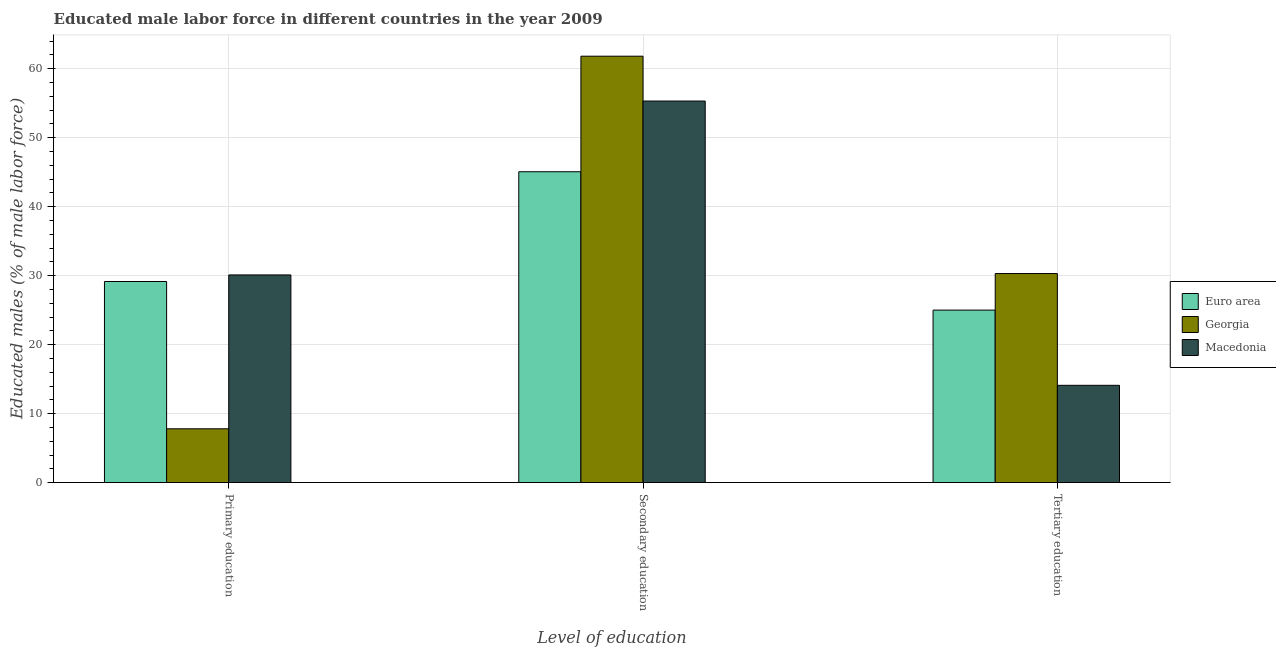Are the number of bars on each tick of the X-axis equal?
Your answer should be very brief. Yes. What is the label of the 2nd group of bars from the left?
Your answer should be very brief. Secondary education. What is the percentage of male labor force who received secondary education in Euro area?
Provide a succinct answer. 45.05. Across all countries, what is the maximum percentage of male labor force who received tertiary education?
Ensure brevity in your answer.  30.3. Across all countries, what is the minimum percentage of male labor force who received primary education?
Ensure brevity in your answer.  7.8. In which country was the percentage of male labor force who received primary education maximum?
Provide a short and direct response. Macedonia. In which country was the percentage of male labor force who received secondary education minimum?
Provide a succinct answer. Euro area. What is the total percentage of male labor force who received tertiary education in the graph?
Provide a succinct answer. 69.4. What is the difference between the percentage of male labor force who received primary education in Euro area and that in Macedonia?
Give a very brief answer. -0.95. What is the difference between the percentage of male labor force who received tertiary education in Macedonia and the percentage of male labor force who received secondary education in Euro area?
Your answer should be very brief. -30.95. What is the average percentage of male labor force who received secondary education per country?
Keep it short and to the point. 54.05. What is the difference between the percentage of male labor force who received tertiary education and percentage of male labor force who received secondary education in Georgia?
Your answer should be compact. -31.5. What is the ratio of the percentage of male labor force who received tertiary education in Euro area to that in Georgia?
Ensure brevity in your answer.  0.83. Is the percentage of male labor force who received secondary education in Georgia less than that in Macedonia?
Provide a succinct answer. No. Is the difference between the percentage of male labor force who received tertiary education in Georgia and Macedonia greater than the difference between the percentage of male labor force who received secondary education in Georgia and Macedonia?
Keep it short and to the point. Yes. What is the difference between the highest and the second highest percentage of male labor force who received primary education?
Your answer should be very brief. 0.95. What is the difference between the highest and the lowest percentage of male labor force who received primary education?
Offer a very short reply. 22.3. In how many countries, is the percentage of male labor force who received primary education greater than the average percentage of male labor force who received primary education taken over all countries?
Your response must be concise. 2. Is the sum of the percentage of male labor force who received tertiary education in Macedonia and Euro area greater than the maximum percentage of male labor force who received primary education across all countries?
Offer a very short reply. Yes. What does the 3rd bar from the left in Tertiary education represents?
Offer a very short reply. Macedonia. What does the 3rd bar from the right in Tertiary education represents?
Give a very brief answer. Euro area. Is it the case that in every country, the sum of the percentage of male labor force who received primary education and percentage of male labor force who received secondary education is greater than the percentage of male labor force who received tertiary education?
Provide a succinct answer. Yes. What is the difference between two consecutive major ticks on the Y-axis?
Your answer should be compact. 10. Are the values on the major ticks of Y-axis written in scientific E-notation?
Ensure brevity in your answer.  No. Does the graph contain any zero values?
Your answer should be very brief. No. Where does the legend appear in the graph?
Provide a succinct answer. Center right. How many legend labels are there?
Provide a short and direct response. 3. What is the title of the graph?
Keep it short and to the point. Educated male labor force in different countries in the year 2009. Does "Middle income" appear as one of the legend labels in the graph?
Ensure brevity in your answer.  No. What is the label or title of the X-axis?
Your response must be concise. Level of education. What is the label or title of the Y-axis?
Provide a succinct answer. Educated males (% of male labor force). What is the Educated males (% of male labor force) of Euro area in Primary education?
Your response must be concise. 29.15. What is the Educated males (% of male labor force) in Georgia in Primary education?
Ensure brevity in your answer.  7.8. What is the Educated males (% of male labor force) in Macedonia in Primary education?
Your answer should be very brief. 30.1. What is the Educated males (% of male labor force) of Euro area in Secondary education?
Your response must be concise. 45.05. What is the Educated males (% of male labor force) in Georgia in Secondary education?
Your answer should be compact. 61.8. What is the Educated males (% of male labor force) in Macedonia in Secondary education?
Offer a very short reply. 55.3. What is the Educated males (% of male labor force) of Euro area in Tertiary education?
Your answer should be compact. 25. What is the Educated males (% of male labor force) in Georgia in Tertiary education?
Your answer should be compact. 30.3. What is the Educated males (% of male labor force) of Macedonia in Tertiary education?
Your answer should be compact. 14.1. Across all Level of education, what is the maximum Educated males (% of male labor force) in Euro area?
Provide a succinct answer. 45.05. Across all Level of education, what is the maximum Educated males (% of male labor force) of Georgia?
Ensure brevity in your answer.  61.8. Across all Level of education, what is the maximum Educated males (% of male labor force) in Macedonia?
Your answer should be compact. 55.3. Across all Level of education, what is the minimum Educated males (% of male labor force) of Euro area?
Your response must be concise. 25. Across all Level of education, what is the minimum Educated males (% of male labor force) in Georgia?
Give a very brief answer. 7.8. Across all Level of education, what is the minimum Educated males (% of male labor force) in Macedonia?
Your response must be concise. 14.1. What is the total Educated males (% of male labor force) in Euro area in the graph?
Your answer should be very brief. 99.2. What is the total Educated males (% of male labor force) in Georgia in the graph?
Offer a terse response. 99.9. What is the total Educated males (% of male labor force) in Macedonia in the graph?
Provide a succinct answer. 99.5. What is the difference between the Educated males (% of male labor force) of Euro area in Primary education and that in Secondary education?
Your answer should be very brief. -15.91. What is the difference between the Educated males (% of male labor force) in Georgia in Primary education and that in Secondary education?
Offer a very short reply. -54. What is the difference between the Educated males (% of male labor force) of Macedonia in Primary education and that in Secondary education?
Offer a very short reply. -25.2. What is the difference between the Educated males (% of male labor force) of Euro area in Primary education and that in Tertiary education?
Your response must be concise. 4.15. What is the difference between the Educated males (% of male labor force) in Georgia in Primary education and that in Tertiary education?
Give a very brief answer. -22.5. What is the difference between the Educated males (% of male labor force) of Macedonia in Primary education and that in Tertiary education?
Offer a very short reply. 16. What is the difference between the Educated males (% of male labor force) in Euro area in Secondary education and that in Tertiary education?
Offer a terse response. 20.05. What is the difference between the Educated males (% of male labor force) in Georgia in Secondary education and that in Tertiary education?
Keep it short and to the point. 31.5. What is the difference between the Educated males (% of male labor force) of Macedonia in Secondary education and that in Tertiary education?
Your answer should be very brief. 41.2. What is the difference between the Educated males (% of male labor force) of Euro area in Primary education and the Educated males (% of male labor force) of Georgia in Secondary education?
Ensure brevity in your answer.  -32.65. What is the difference between the Educated males (% of male labor force) in Euro area in Primary education and the Educated males (% of male labor force) in Macedonia in Secondary education?
Make the answer very short. -26.15. What is the difference between the Educated males (% of male labor force) in Georgia in Primary education and the Educated males (% of male labor force) in Macedonia in Secondary education?
Your response must be concise. -47.5. What is the difference between the Educated males (% of male labor force) in Euro area in Primary education and the Educated males (% of male labor force) in Georgia in Tertiary education?
Keep it short and to the point. -1.15. What is the difference between the Educated males (% of male labor force) in Euro area in Primary education and the Educated males (% of male labor force) in Macedonia in Tertiary education?
Provide a succinct answer. 15.05. What is the difference between the Educated males (% of male labor force) of Euro area in Secondary education and the Educated males (% of male labor force) of Georgia in Tertiary education?
Keep it short and to the point. 14.75. What is the difference between the Educated males (% of male labor force) of Euro area in Secondary education and the Educated males (% of male labor force) of Macedonia in Tertiary education?
Give a very brief answer. 30.95. What is the difference between the Educated males (% of male labor force) in Georgia in Secondary education and the Educated males (% of male labor force) in Macedonia in Tertiary education?
Provide a short and direct response. 47.7. What is the average Educated males (% of male labor force) of Euro area per Level of education?
Provide a short and direct response. 33.07. What is the average Educated males (% of male labor force) of Georgia per Level of education?
Provide a short and direct response. 33.3. What is the average Educated males (% of male labor force) in Macedonia per Level of education?
Offer a very short reply. 33.17. What is the difference between the Educated males (% of male labor force) in Euro area and Educated males (% of male labor force) in Georgia in Primary education?
Provide a short and direct response. 21.35. What is the difference between the Educated males (% of male labor force) in Euro area and Educated males (% of male labor force) in Macedonia in Primary education?
Your response must be concise. -0.95. What is the difference between the Educated males (% of male labor force) in Georgia and Educated males (% of male labor force) in Macedonia in Primary education?
Your response must be concise. -22.3. What is the difference between the Educated males (% of male labor force) in Euro area and Educated males (% of male labor force) in Georgia in Secondary education?
Your answer should be compact. -16.75. What is the difference between the Educated males (% of male labor force) of Euro area and Educated males (% of male labor force) of Macedonia in Secondary education?
Ensure brevity in your answer.  -10.25. What is the difference between the Educated males (% of male labor force) in Euro area and Educated males (% of male labor force) in Georgia in Tertiary education?
Your answer should be compact. -5.3. What is the difference between the Educated males (% of male labor force) in Euro area and Educated males (% of male labor force) in Macedonia in Tertiary education?
Make the answer very short. 10.9. What is the difference between the Educated males (% of male labor force) of Georgia and Educated males (% of male labor force) of Macedonia in Tertiary education?
Your answer should be very brief. 16.2. What is the ratio of the Educated males (% of male labor force) in Euro area in Primary education to that in Secondary education?
Ensure brevity in your answer.  0.65. What is the ratio of the Educated males (% of male labor force) of Georgia in Primary education to that in Secondary education?
Give a very brief answer. 0.13. What is the ratio of the Educated males (% of male labor force) in Macedonia in Primary education to that in Secondary education?
Your answer should be very brief. 0.54. What is the ratio of the Educated males (% of male labor force) in Euro area in Primary education to that in Tertiary education?
Give a very brief answer. 1.17. What is the ratio of the Educated males (% of male labor force) of Georgia in Primary education to that in Tertiary education?
Offer a terse response. 0.26. What is the ratio of the Educated males (% of male labor force) of Macedonia in Primary education to that in Tertiary education?
Your answer should be compact. 2.13. What is the ratio of the Educated males (% of male labor force) of Euro area in Secondary education to that in Tertiary education?
Provide a succinct answer. 1.8. What is the ratio of the Educated males (% of male labor force) in Georgia in Secondary education to that in Tertiary education?
Your answer should be compact. 2.04. What is the ratio of the Educated males (% of male labor force) of Macedonia in Secondary education to that in Tertiary education?
Your answer should be very brief. 3.92. What is the difference between the highest and the second highest Educated males (% of male labor force) in Euro area?
Your answer should be very brief. 15.91. What is the difference between the highest and the second highest Educated males (% of male labor force) of Georgia?
Give a very brief answer. 31.5. What is the difference between the highest and the second highest Educated males (% of male labor force) in Macedonia?
Give a very brief answer. 25.2. What is the difference between the highest and the lowest Educated males (% of male labor force) of Euro area?
Your response must be concise. 20.05. What is the difference between the highest and the lowest Educated males (% of male labor force) in Georgia?
Ensure brevity in your answer.  54. What is the difference between the highest and the lowest Educated males (% of male labor force) in Macedonia?
Offer a very short reply. 41.2. 